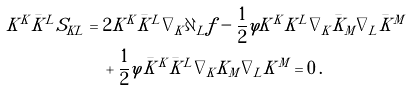Convert formula to latex. <formula><loc_0><loc_0><loc_500><loc_500>K ^ { K } \bar { K } ^ { L } S _ { K L } & = 2 K ^ { K } \bar { K } ^ { L } \nabla _ { K } \partial _ { L } { f } - \frac { 1 } { 2 } \varphi K ^ { K } K ^ { L } \nabla _ { K } { \bar { K } _ { M } } \nabla _ { L } { \bar { K } ^ { M } } \\ & \quad + \frac { 1 } { 2 } \varphi \bar { K } ^ { K } \bar { K } ^ { L } \nabla _ { K } { K _ { M } } \nabla _ { L } { K ^ { M } } = 0 \, .</formula> 